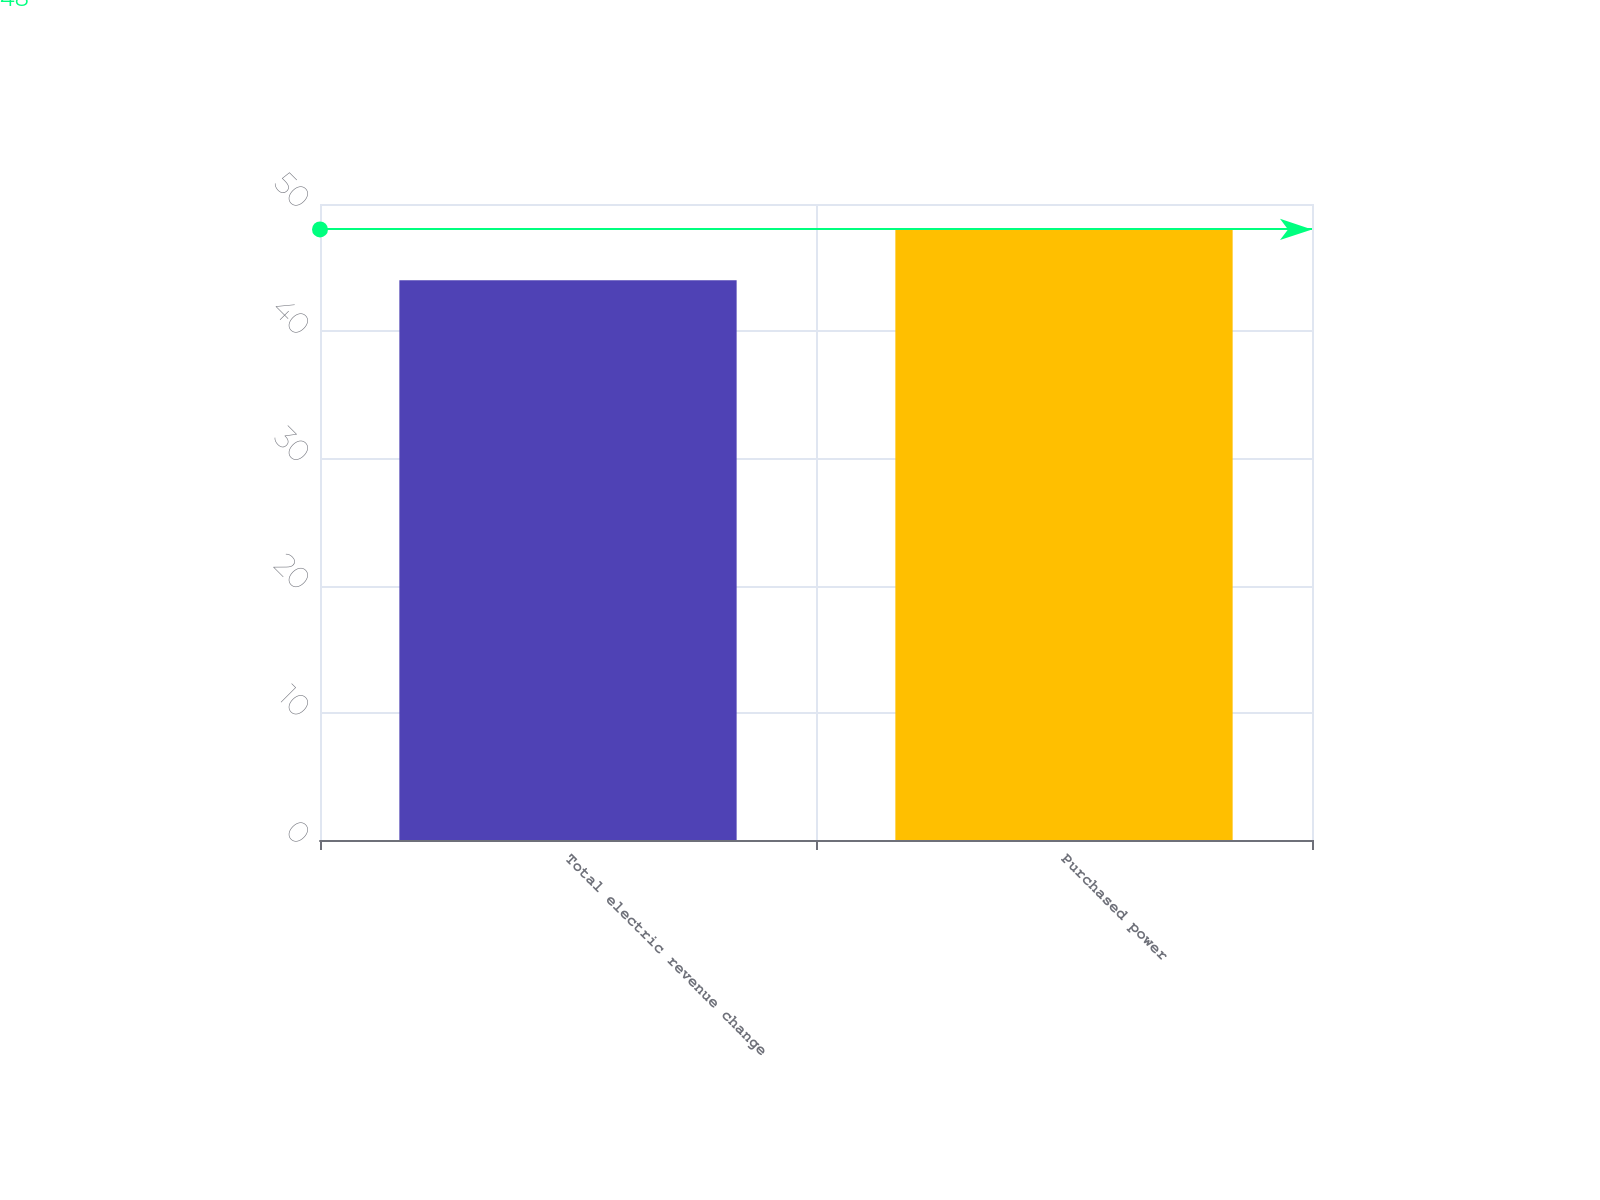<chart> <loc_0><loc_0><loc_500><loc_500><bar_chart><fcel>Total electric revenue change<fcel>Purchased power<nl><fcel>44<fcel>48<nl></chart> 